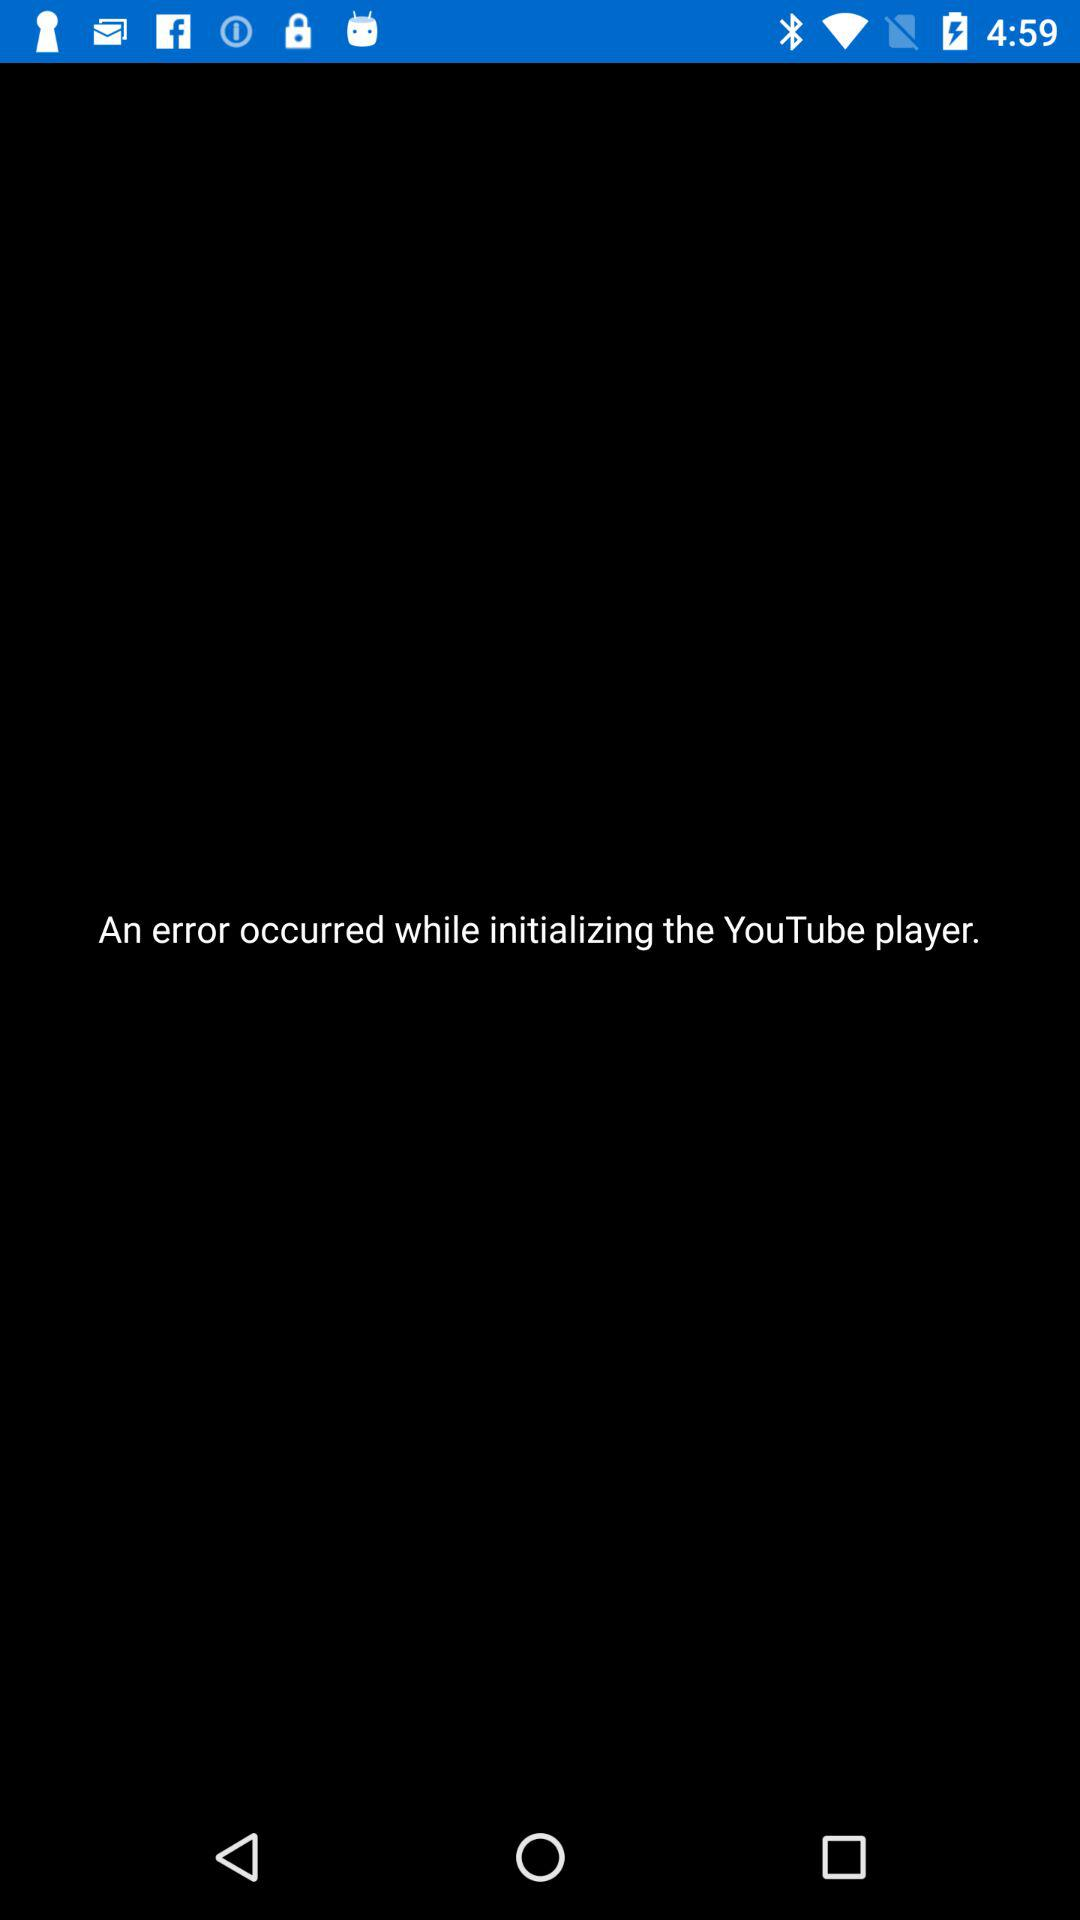What happened while initialising the YouTube player? There was an error that occurred while initialising the YouTube player. 